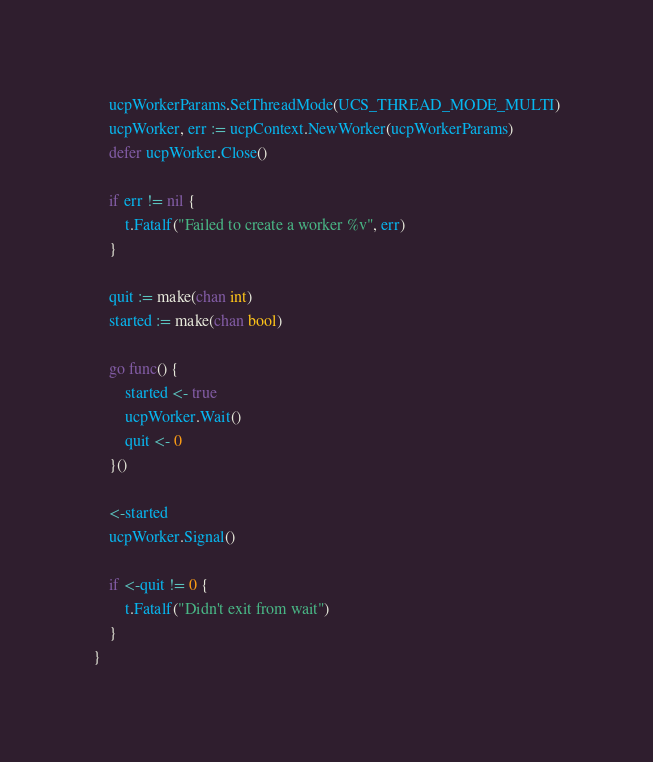Convert code to text. <code><loc_0><loc_0><loc_500><loc_500><_Go_>	ucpWorkerParams.SetThreadMode(UCS_THREAD_MODE_MULTI)
	ucpWorker, err := ucpContext.NewWorker(ucpWorkerParams)
	defer ucpWorker.Close()

	if err != nil {
		t.Fatalf("Failed to create a worker %v", err)
	}

	quit := make(chan int)
	started := make(chan bool)

	go func() {
		started <- true
		ucpWorker.Wait()
		quit <- 0
	}()

	<-started
	ucpWorker.Signal()

	if <-quit != 0 {
		t.Fatalf("Didn't exit from wait")
	}
}
</code> 